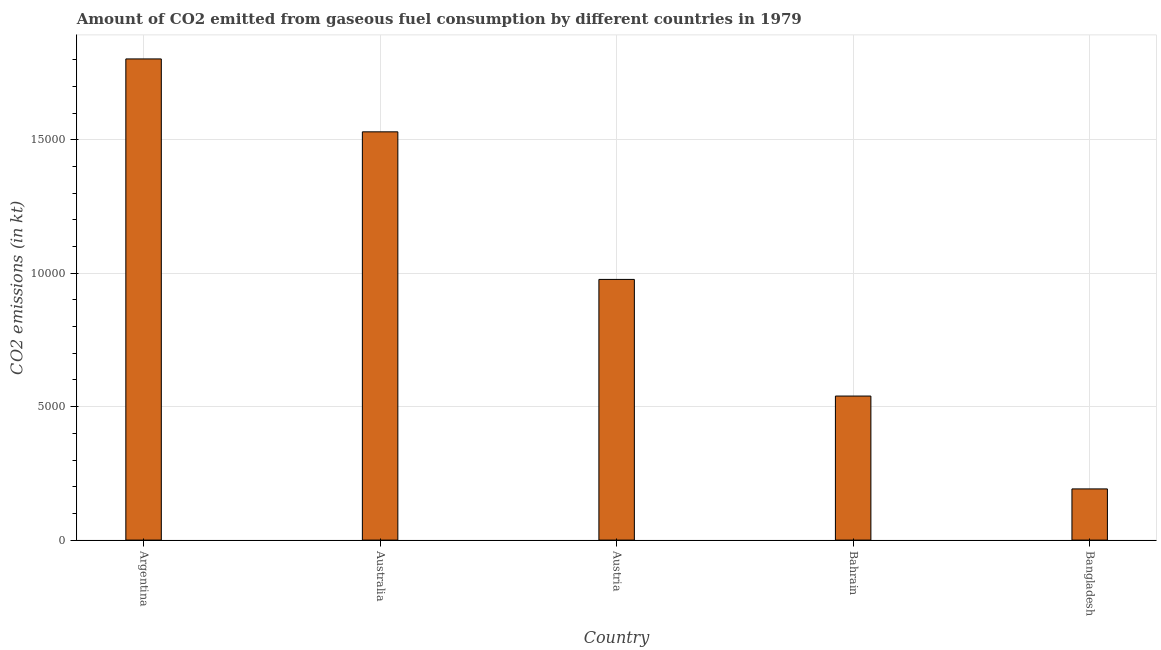Does the graph contain any zero values?
Your answer should be compact. No. What is the title of the graph?
Your answer should be compact. Amount of CO2 emitted from gaseous fuel consumption by different countries in 1979. What is the label or title of the X-axis?
Provide a short and direct response. Country. What is the label or title of the Y-axis?
Ensure brevity in your answer.  CO2 emissions (in kt). What is the co2 emissions from gaseous fuel consumption in Austria?
Offer a very short reply. 9768.89. Across all countries, what is the maximum co2 emissions from gaseous fuel consumption?
Give a very brief answer. 1.80e+04. Across all countries, what is the minimum co2 emissions from gaseous fuel consumption?
Your answer should be compact. 1917.84. In which country was the co2 emissions from gaseous fuel consumption maximum?
Offer a very short reply. Argentina. What is the sum of the co2 emissions from gaseous fuel consumption?
Offer a terse response. 5.04e+04. What is the difference between the co2 emissions from gaseous fuel consumption in Australia and Austria?
Provide a short and direct response. 5529.84. What is the average co2 emissions from gaseous fuel consumption per country?
Provide a succinct answer. 1.01e+04. What is the median co2 emissions from gaseous fuel consumption?
Your response must be concise. 9768.89. What is the ratio of the co2 emissions from gaseous fuel consumption in Argentina to that in Bangladesh?
Make the answer very short. 9.4. Is the difference between the co2 emissions from gaseous fuel consumption in Australia and Bangladesh greater than the difference between any two countries?
Give a very brief answer. No. What is the difference between the highest and the second highest co2 emissions from gaseous fuel consumption?
Give a very brief answer. 2731.91. What is the difference between the highest and the lowest co2 emissions from gaseous fuel consumption?
Ensure brevity in your answer.  1.61e+04. How many bars are there?
Make the answer very short. 5. How many countries are there in the graph?
Give a very brief answer. 5. What is the difference between two consecutive major ticks on the Y-axis?
Your answer should be very brief. 5000. What is the CO2 emissions (in kt) of Argentina?
Offer a very short reply. 1.80e+04. What is the CO2 emissions (in kt) of Australia?
Provide a short and direct response. 1.53e+04. What is the CO2 emissions (in kt) of Austria?
Ensure brevity in your answer.  9768.89. What is the CO2 emissions (in kt) in Bahrain?
Provide a short and direct response. 5397.82. What is the CO2 emissions (in kt) of Bangladesh?
Ensure brevity in your answer.  1917.84. What is the difference between the CO2 emissions (in kt) in Argentina and Australia?
Ensure brevity in your answer.  2731.91. What is the difference between the CO2 emissions (in kt) in Argentina and Austria?
Provide a succinct answer. 8261.75. What is the difference between the CO2 emissions (in kt) in Argentina and Bahrain?
Keep it short and to the point. 1.26e+04. What is the difference between the CO2 emissions (in kt) in Argentina and Bangladesh?
Give a very brief answer. 1.61e+04. What is the difference between the CO2 emissions (in kt) in Australia and Austria?
Offer a very short reply. 5529.84. What is the difference between the CO2 emissions (in kt) in Australia and Bahrain?
Give a very brief answer. 9900.9. What is the difference between the CO2 emissions (in kt) in Australia and Bangladesh?
Ensure brevity in your answer.  1.34e+04. What is the difference between the CO2 emissions (in kt) in Austria and Bahrain?
Offer a very short reply. 4371.06. What is the difference between the CO2 emissions (in kt) in Austria and Bangladesh?
Offer a very short reply. 7851.05. What is the difference between the CO2 emissions (in kt) in Bahrain and Bangladesh?
Offer a terse response. 3479.98. What is the ratio of the CO2 emissions (in kt) in Argentina to that in Australia?
Your response must be concise. 1.18. What is the ratio of the CO2 emissions (in kt) in Argentina to that in Austria?
Provide a succinct answer. 1.85. What is the ratio of the CO2 emissions (in kt) in Argentina to that in Bahrain?
Your answer should be very brief. 3.34. What is the ratio of the CO2 emissions (in kt) in Argentina to that in Bangladesh?
Your answer should be very brief. 9.4. What is the ratio of the CO2 emissions (in kt) in Australia to that in Austria?
Offer a terse response. 1.57. What is the ratio of the CO2 emissions (in kt) in Australia to that in Bahrain?
Your answer should be very brief. 2.83. What is the ratio of the CO2 emissions (in kt) in Australia to that in Bangladesh?
Your answer should be compact. 7.98. What is the ratio of the CO2 emissions (in kt) in Austria to that in Bahrain?
Your response must be concise. 1.81. What is the ratio of the CO2 emissions (in kt) in Austria to that in Bangladesh?
Your response must be concise. 5.09. What is the ratio of the CO2 emissions (in kt) in Bahrain to that in Bangladesh?
Keep it short and to the point. 2.81. 